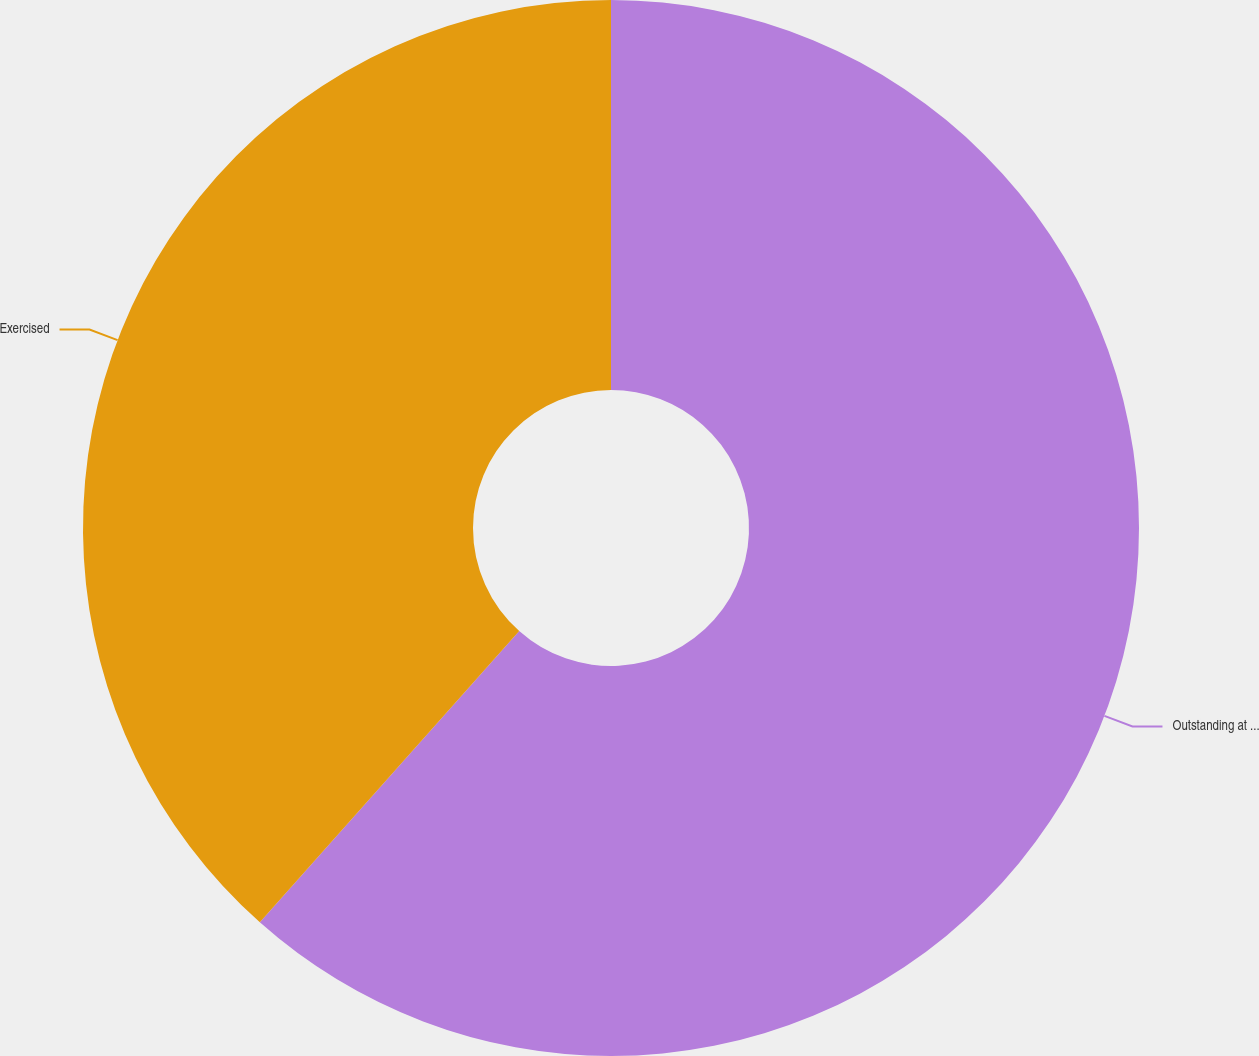<chart> <loc_0><loc_0><loc_500><loc_500><pie_chart><fcel>Outstanding at beginning of<fcel>Exercised<nl><fcel>61.58%<fcel>38.42%<nl></chart> 